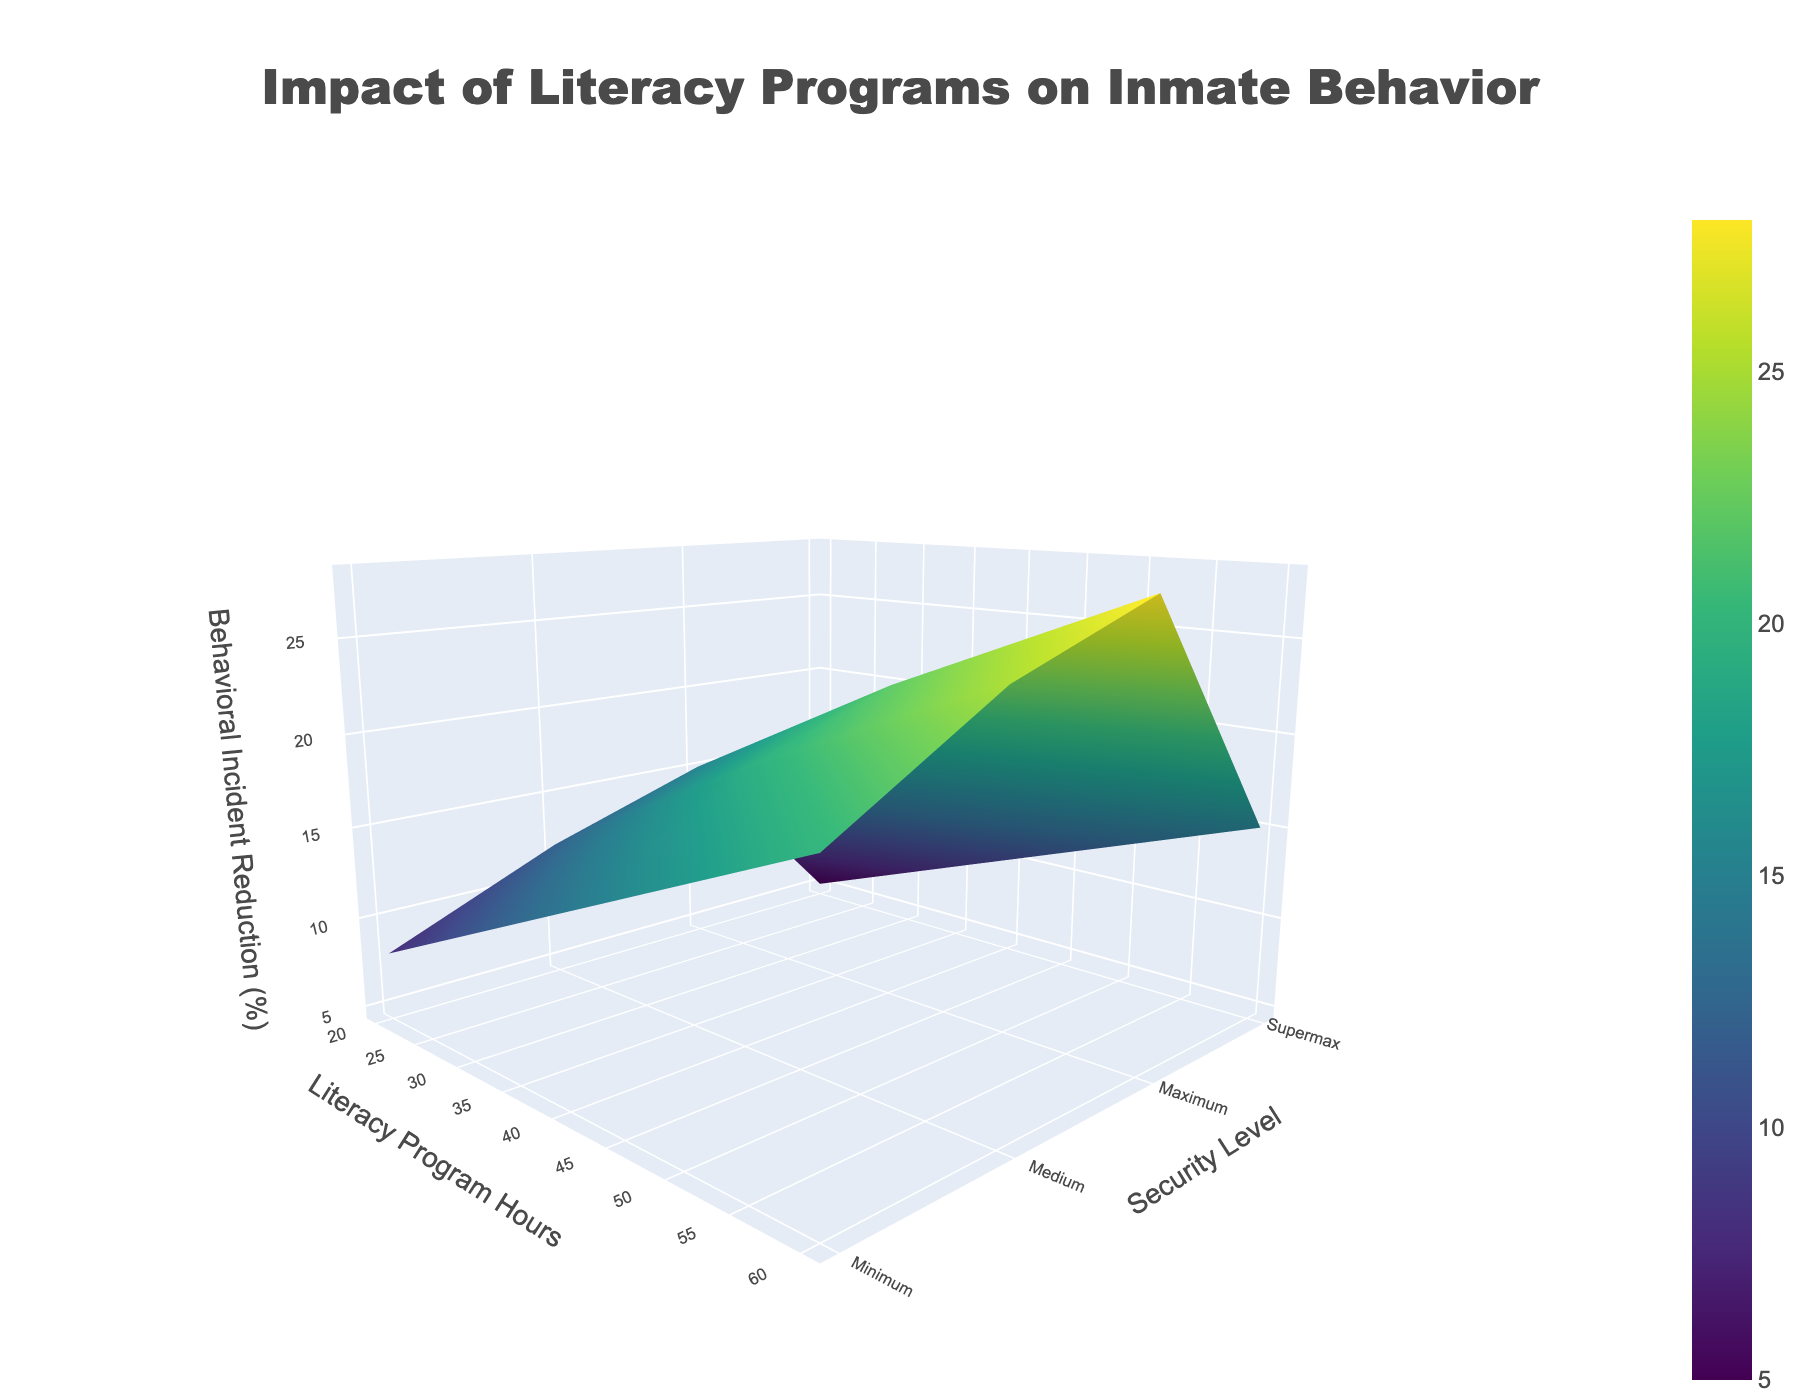What is the title of the 3D surface plot? The title of the plot is typically found at the top. It summarises the content of the plot in a concise manner. For this plot, the title reads "Impact of Literacy Programs on Inmate Behavior".
Answer: Impact of Literacy Programs on Inmate Behavior What does the z-axis represent in the figure? The z-axis is labeled with a title that indicates its representation. In this plot, the z-axis is titled "Behavioral Incident Reduction (%)", showing the percentage reduction in behavioral incidents.
Answer: Behavioral Incident Reduction (%) Which security level shows the highest reduction in behavioral incidents with 60 literacy program hours? To find the highest reduction for 60 program hours, trace the z-values (height) for each security level along the x-axis where it corresponds to 60 hours. The highest z-value is at the 'Minimum' security level.
Answer: Minimum Compare the behavioral incident reduction in 'Medium' security level at 20 hours and 60 hours of literacy programs. Observe the z-values (heights) for 'Medium' security level at 20 and 60 program hours. At 20 hours, the reduction is 12%, and at 60 hours, it is 25%. 25% is greater than 12%.
Answer: 25% is greater than 12% What is the general trend in behavioral incident reduction as literacy program hours increase for 'Supermax' security level? Look at the z-values for 'Supermax' security level across different program hours. As hours increase from 20 to 40 to 60, the z-values increase from 5% to 10% to 15%, indicating an upward trend.
Answer: Increases How does the reduction in behavioral incidents at 40 hours of literacy program compare between 'Minimum' and 'Supermax' security levels? Compare the z-values for 40 program hours for both 'Minimum' and 'Supermax' security levels. The reductions are 22% (Minimum) and 10% (Supermax). 22% is higher than 10%.
Answer: 22% is higher than 10% Calculate the average behavioral incident reduction for 'Medium' security level across all literacy program hours. Sum the reductions for 'Medium' security level at all program hours (12 + 19 + 25) and divide by the number of data points (3). The calculation is (12 + 19 + 25) / 3 = 56 / 3 ≈ 18.67%.
Answer: 18.67% What's the difference in behavioral incident reduction between 'Minimum' and 'Maximum' security levels at 20 hours of literacy programs? Find the z-values for 20 hours of literacy programs for 'Minimum' (15%) and 'Maximum' (8%) security levels, then subtract the smaller from the larger: 15% - 8% = 7%.
Answer: 7% Which security level shows the least improvement in behavioral incidents with 20 literacy program hours? Look for the smallest z-value at 20 hours among all security levels. The value at 'Supermax' (5%) is the smallest.
Answer: Supermax Describe the surface color pattern observed in the figure. The plot uses a 'Viridis' colorscale, ranging from dark purple to yellow. Areas with higher reductions (%) are lighter (yellow), while lower reductions are darker (purple).
Answer: Dark purple to yellow, higher is lighter 